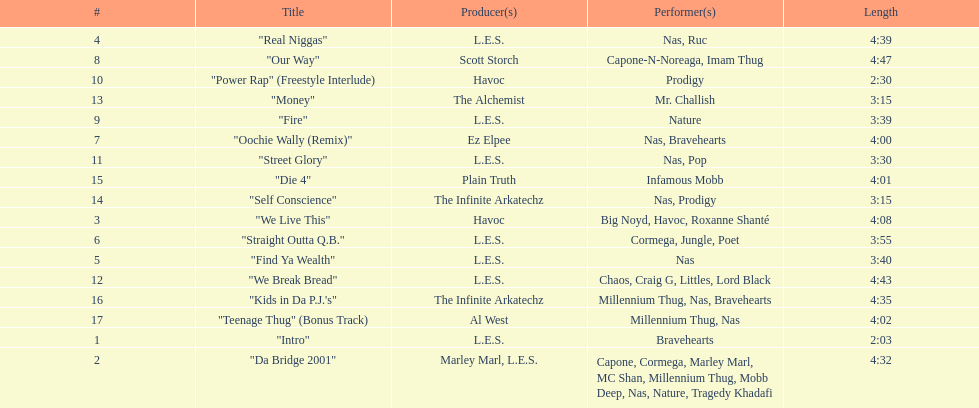After street glory, what song is listed? "We Break Bread". 